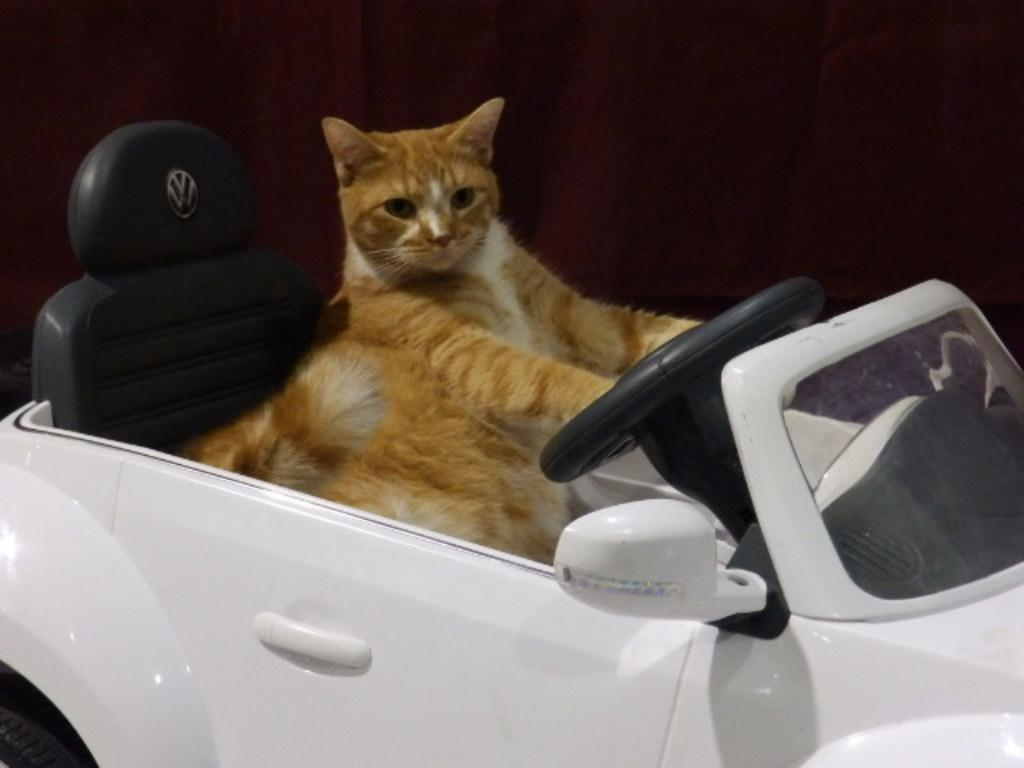What type of animal is in the image? There is a cat in the image. What is the cat doing or situated in? The cat is in a toy car. What type of lipstick is the cat wearing in the image? There is no lipstick or any indication of the cat wearing lipstick in the image. 